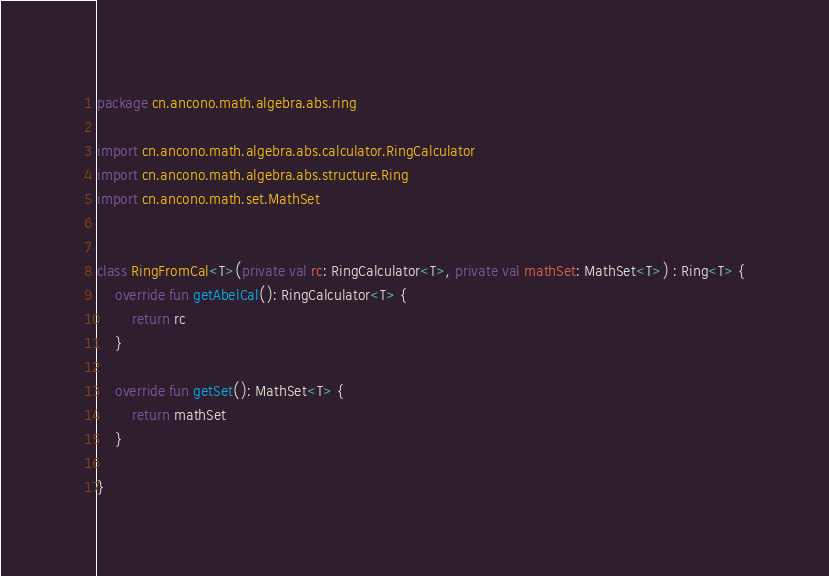<code> <loc_0><loc_0><loc_500><loc_500><_Kotlin_>package cn.ancono.math.algebra.abs.ring

import cn.ancono.math.algebra.abs.calculator.RingCalculator
import cn.ancono.math.algebra.abs.structure.Ring
import cn.ancono.math.set.MathSet


class RingFromCal<T>(private val rc: RingCalculator<T>, private val mathSet: MathSet<T>) : Ring<T> {
    override fun getAbelCal(): RingCalculator<T> {
        return rc
    }

    override fun getSet(): MathSet<T> {
        return mathSet
    }

}
</code> 